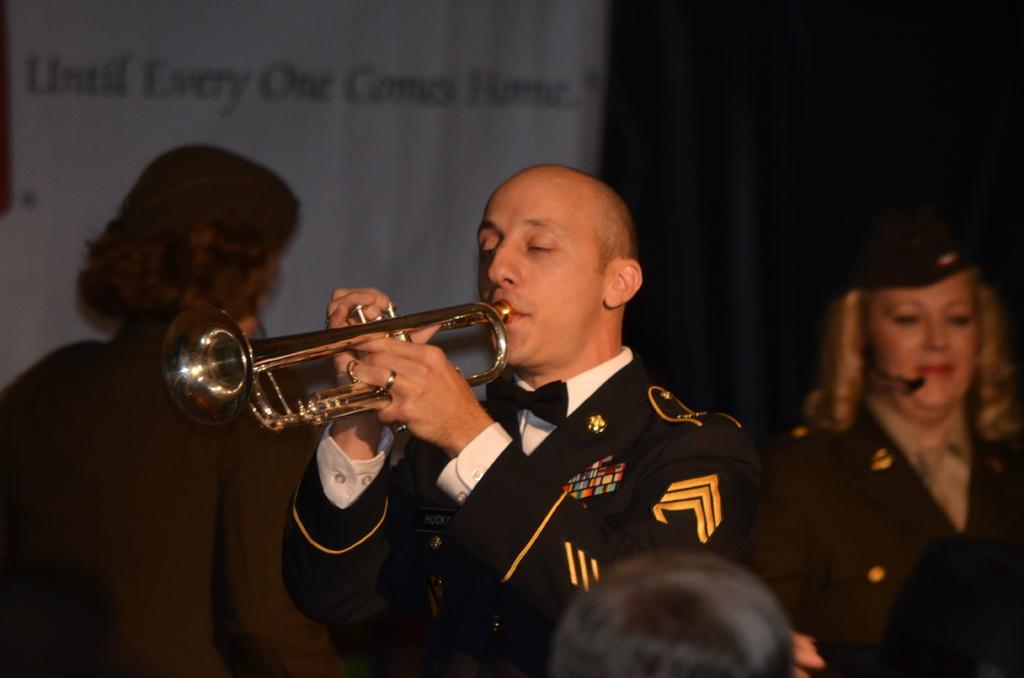Could you give a brief overview of what you see in this image? This picture seems to be clicked inside. In the foreground we can see the head of a person. In the center there is a man wearing uniform and playing trumpet. In the background we can see the two persons seems to be standing and we can see the curtain and a white color banner on which the text is printed. 